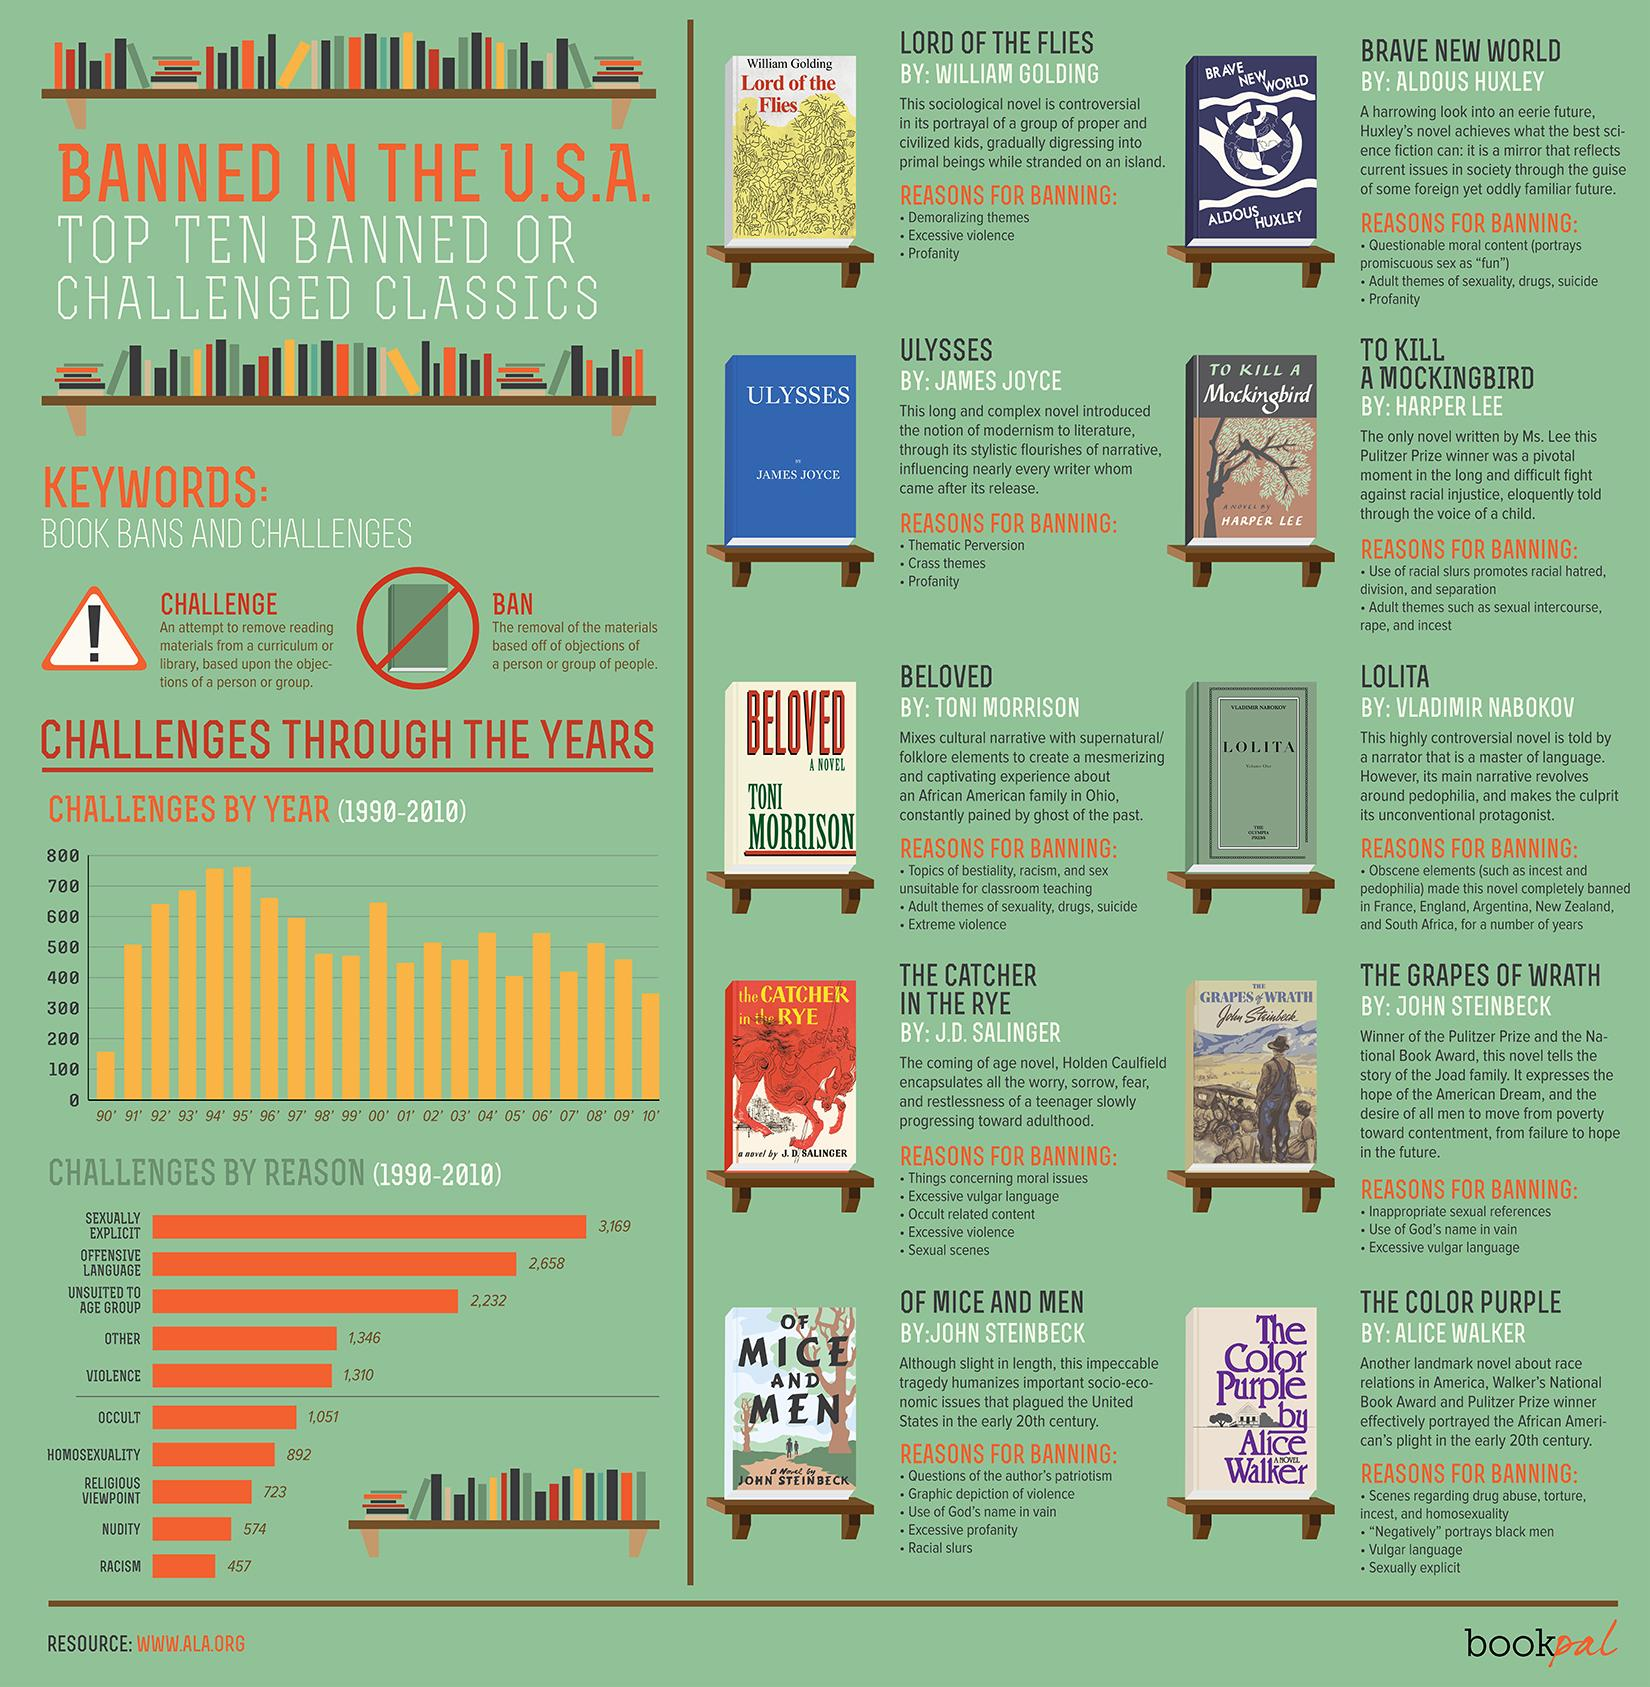Identify some key points in this picture. A total of 5,827 books were challenged because of sexual explicit or offensive language. The second most significant reason for the challenge is offensive language. The top reason for challenge is sexuality being explicit. In the years from 1990 to 2010, the greatest number of challenges occurred in 1995. There are 12 years in the bar chart that contains 500 or more challenges. 